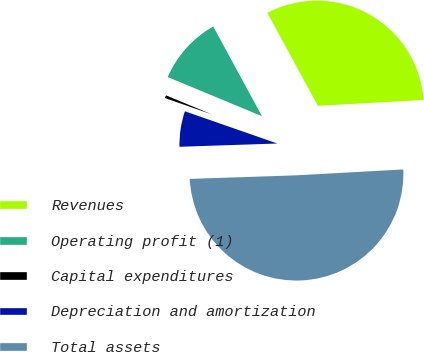<chart> <loc_0><loc_0><loc_500><loc_500><pie_chart><fcel>Revenues<fcel>Operating profit (1)<fcel>Capital expenditures<fcel>Depreciation and amortization<fcel>Total assets<nl><fcel>32.04%<fcel>10.81%<fcel>0.93%<fcel>5.87%<fcel>50.34%<nl></chart> 